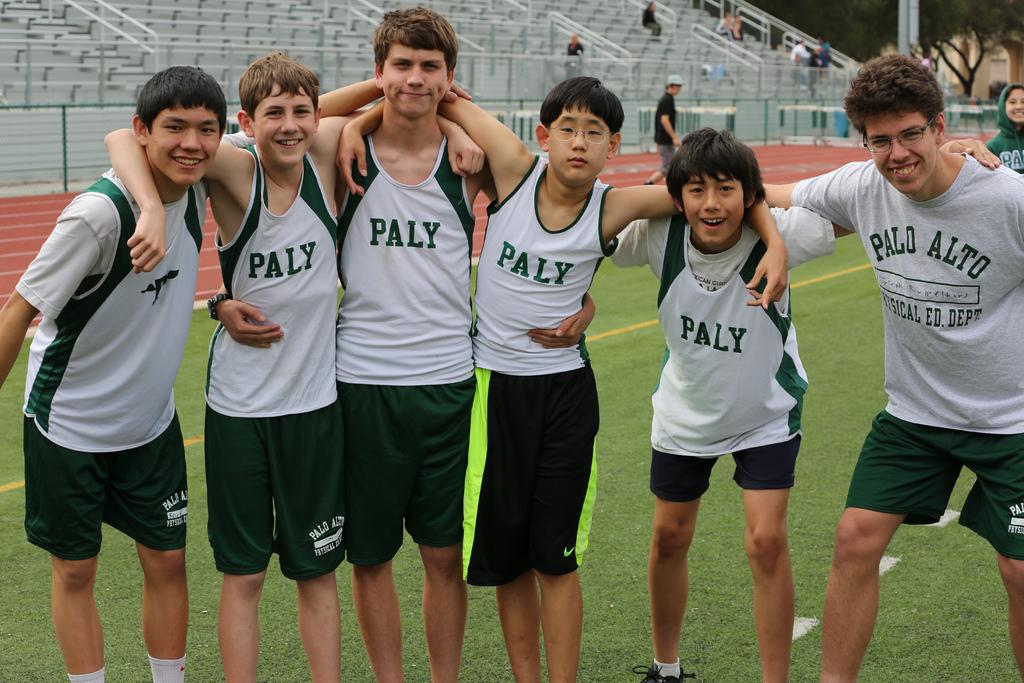How many people are in the group in the image? There is a group of people in the image, but the exact number is not specified. What are some of the people in the group doing? Some people in the group are standing, and some are watching. What can be seen in the background of the image? In the background of the image, there is a stadium, a fence, rods, trees, and a pole. Can you describe the people in the background? There are people in the background of the image, but their actions or positions are not specified. What type of brass instruments are being played by the ducks in the image? There are no ducks or brass instruments present in the image. How many ducks are in the flock that is visible in the image? There are no ducks or flocks present in the image. 